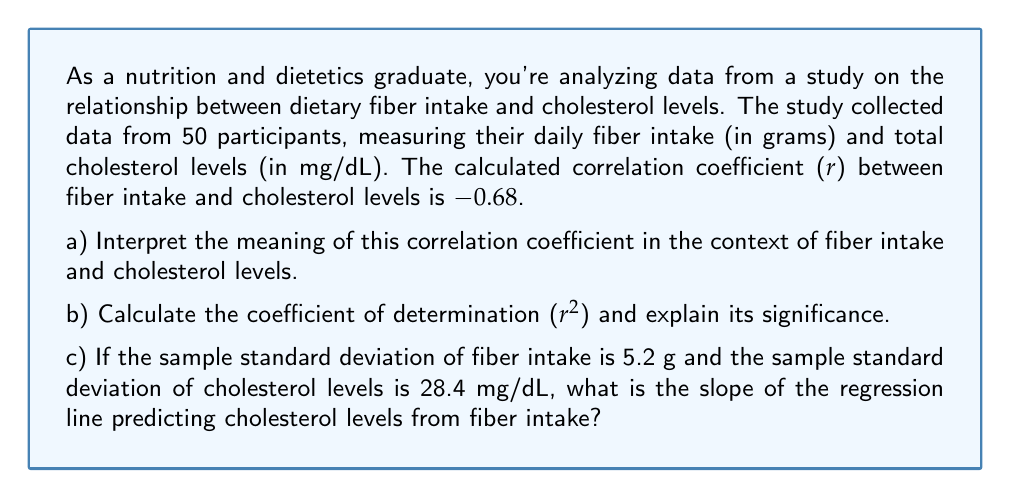Give your solution to this math problem. Let's approach this step-by-step:

a) The correlation coefficient r = -0.68 indicates a moderately strong negative linear relationship between fiber intake and cholesterol levels. This means that as fiber intake increases, cholesterol levels tend to decrease, and vice versa. The negative sign indicates the inverse relationship, while the magnitude (0.68) suggests a relatively strong correlation.

b) The coefficient of determination (r²) is calculated by squaring the correlation coefficient:

   $$r^2 = (-0.68)^2 = 0.4624$$

   This means that approximately 46.24% of the variation in cholesterol levels can be explained by the variation in fiber intake (or vice versa). It indicates the proportion of shared variance between the two variables.

c) To find the slope of the regression line, we can use the formula:

   $$b = r \cdot \frac{s_y}{s_x}$$

   Where:
   $b$ is the slope
   $r$ is the correlation coefficient
   $s_y$ is the standard deviation of the dependent variable (cholesterol levels)
   $s_x$ is the standard deviation of the independent variable (fiber intake)

   Plugging in the values:

   $$b = -0.68 \cdot \frac{28.4}{5.2} = -3.71$$

   This means that for each gram increase in fiber intake, we expect a decrease of 3.71 mg/dL in cholesterol levels, on average.
Answer: a) Moderately strong negative relationship
b) $r^2 = 0.4624$, 46.24% shared variance
c) Slope = -3.71 mg/dL/g 